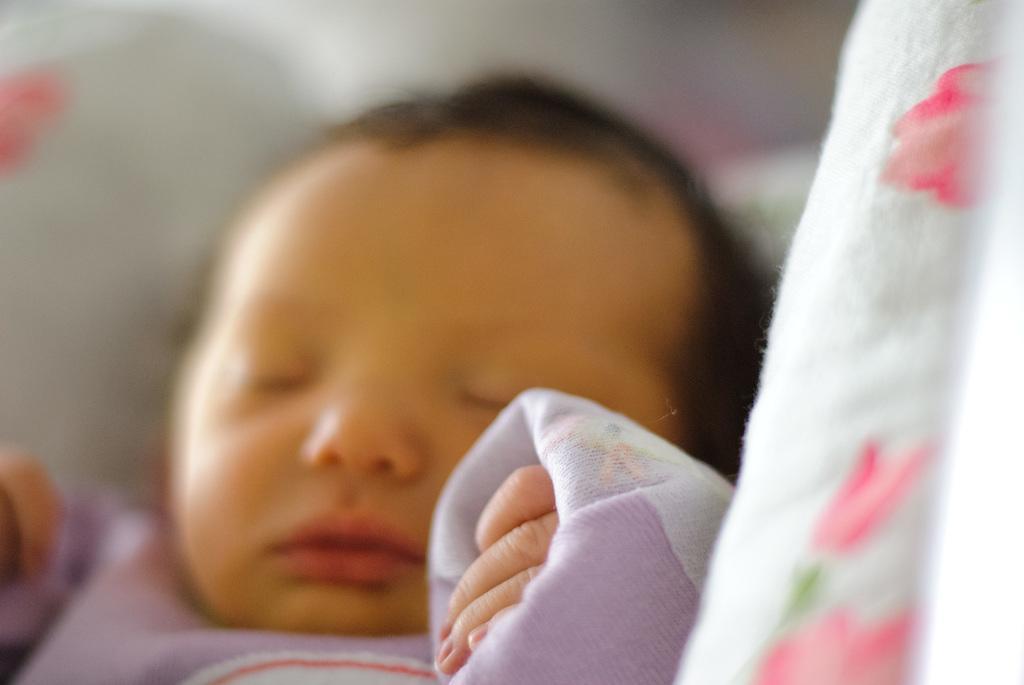Describe this image in one or two sentences. In this image we can see a baby sleeping on the bed. There is a blur background at the top of the image. 